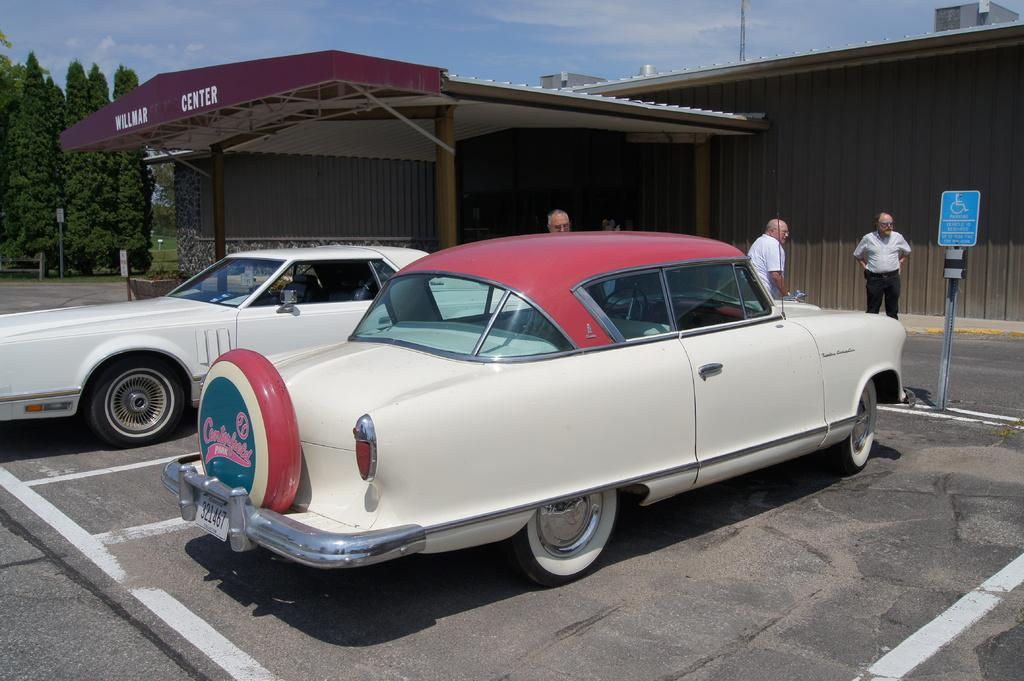What type of vehicles can be seen in the image? There are cars in the image. What type of temporary shelters are present in the image? There are tents in the image. What is the purpose of the signboard in the image? The purpose of the signboard in the image is to provide information or directions. What type of natural vegetation is present in the image? There are trees in the image. What is visible at the top of the image? The sky is visible at the top of the image. What type of barrier is present in the image? There is a fence in the image. How many persons are visible on the road in the middle of the image? There are three persons visible on the road in the middle of the image. Can you see any tigers walking on the road in the image? There are no tigers present in the image; only cars, tents, a signboard, trees, the sky, a fence, and three persons are visible. What type of thread is being used to sew the tents in the image? There is no information about the type of thread used to sew the tents in the image, as the focus is on the presence of the tents and not their construction. 